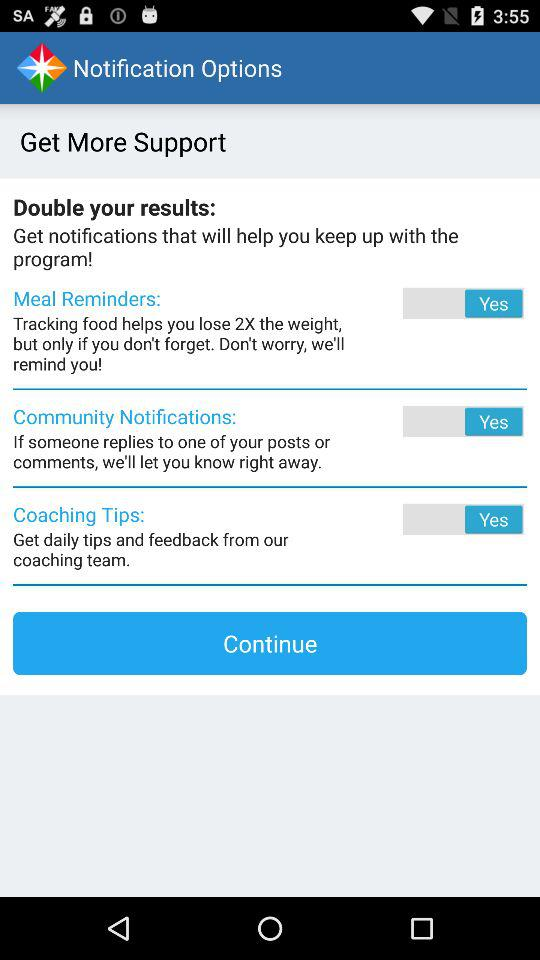What is the status of "Coaching Tips"? The status is "Yes". 